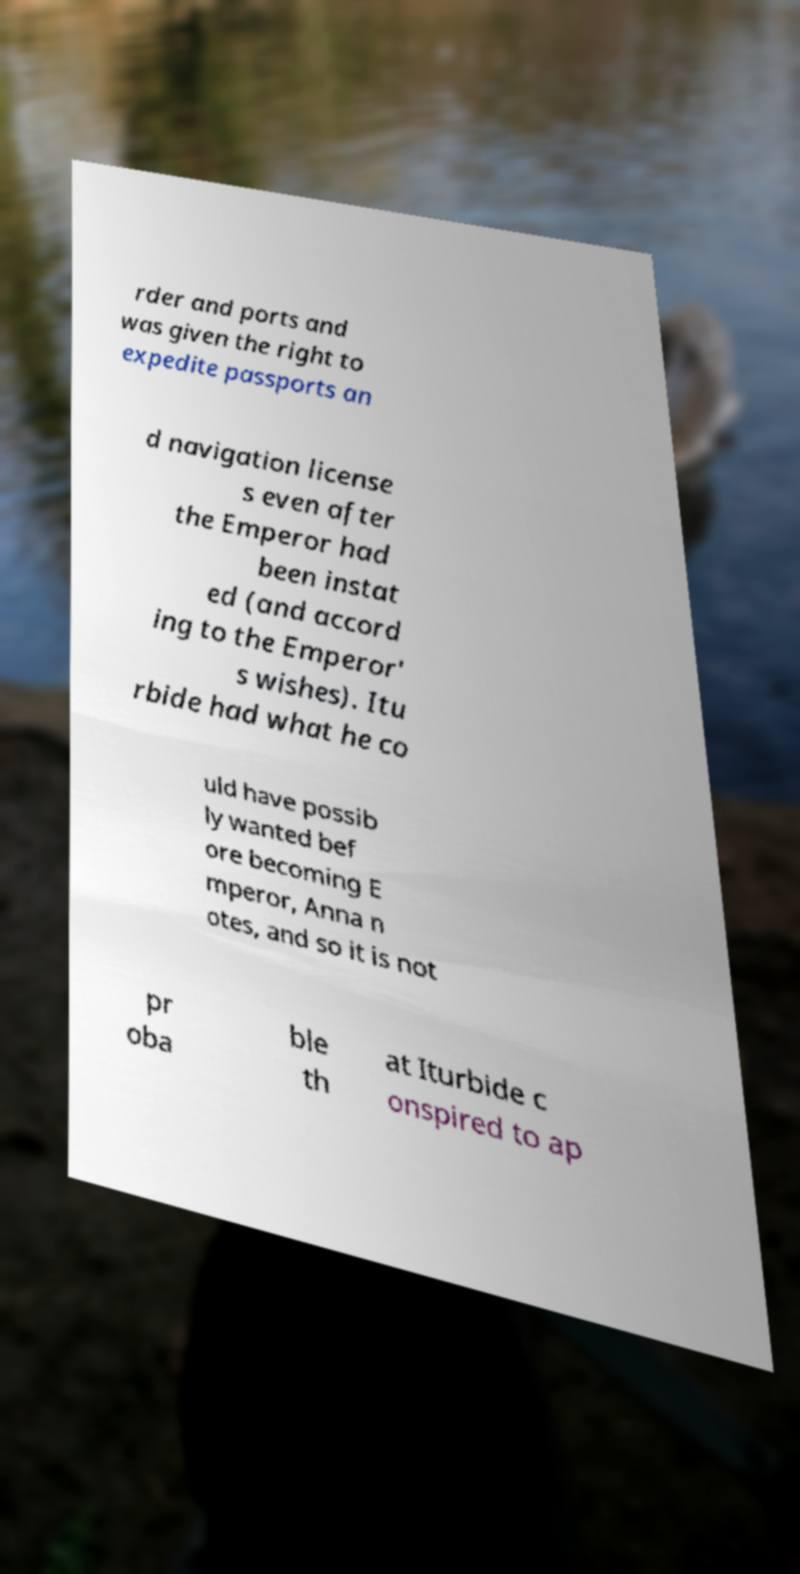Can you read and provide the text displayed in the image?This photo seems to have some interesting text. Can you extract and type it out for me? rder and ports and was given the right to expedite passports an d navigation license s even after the Emperor had been instat ed (and accord ing to the Emperor' s wishes). Itu rbide had what he co uld have possib ly wanted bef ore becoming E mperor, Anna n otes, and so it is not pr oba ble th at Iturbide c onspired to ap 